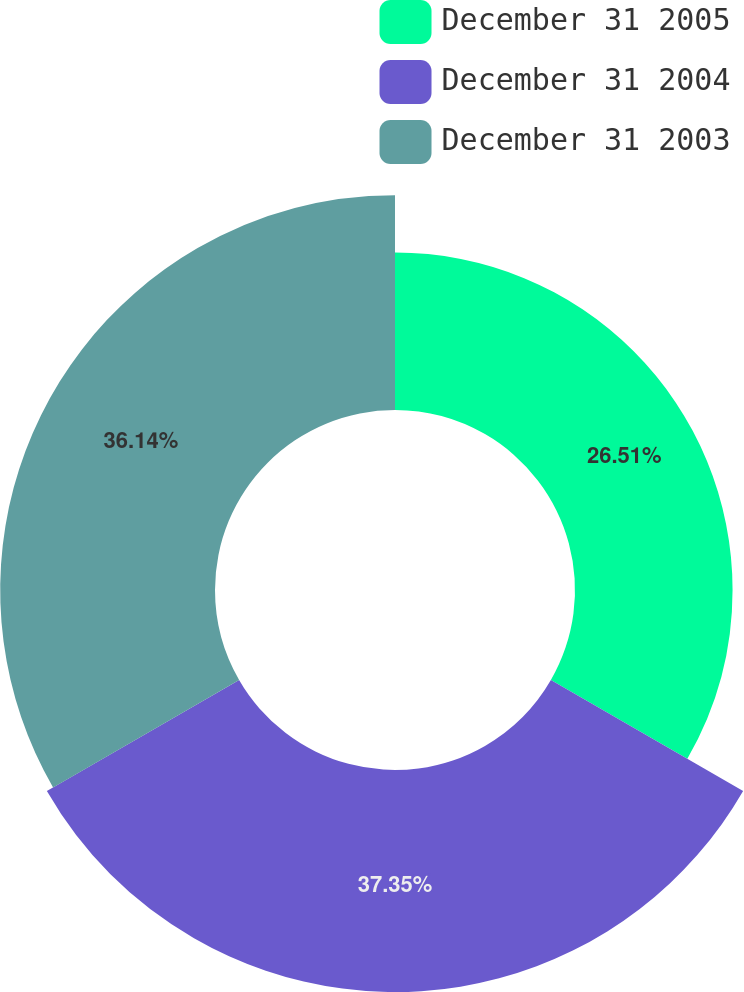<chart> <loc_0><loc_0><loc_500><loc_500><pie_chart><fcel>December 31 2005<fcel>December 31 2004<fcel>December 31 2003<nl><fcel>26.51%<fcel>37.35%<fcel>36.14%<nl></chart> 